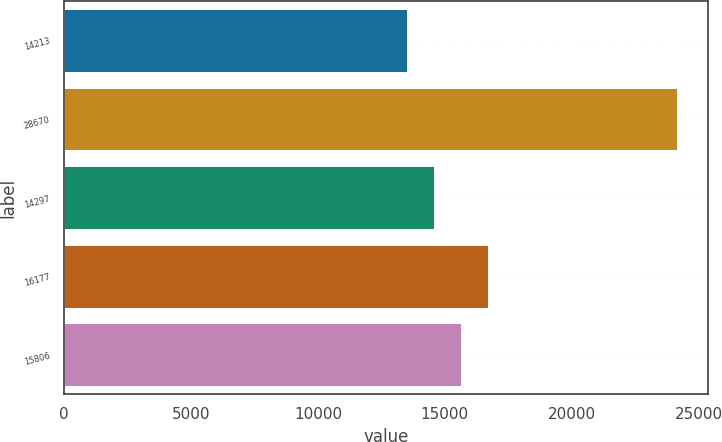Convert chart to OTSL. <chart><loc_0><loc_0><loc_500><loc_500><bar_chart><fcel>14213<fcel>28670<fcel>14297<fcel>16177<fcel>15806<nl><fcel>13514<fcel>24155<fcel>14578.1<fcel>16706.3<fcel>15642.2<nl></chart> 